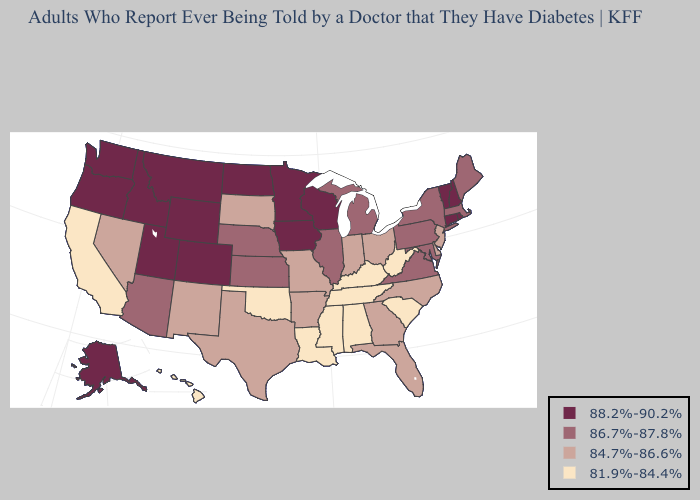How many symbols are there in the legend?
Be succinct. 4. Name the states that have a value in the range 88.2%-90.2%?
Answer briefly. Alaska, Colorado, Connecticut, Idaho, Iowa, Minnesota, Montana, New Hampshire, North Dakota, Oregon, Rhode Island, Utah, Vermont, Washington, Wisconsin, Wyoming. Which states have the highest value in the USA?
Concise answer only. Alaska, Colorado, Connecticut, Idaho, Iowa, Minnesota, Montana, New Hampshire, North Dakota, Oregon, Rhode Island, Utah, Vermont, Washington, Wisconsin, Wyoming. Does the first symbol in the legend represent the smallest category?
Keep it brief. No. What is the highest value in states that border California?
Short answer required. 88.2%-90.2%. Among the states that border Missouri , which have the highest value?
Be succinct. Iowa. Name the states that have a value in the range 81.9%-84.4%?
Concise answer only. Alabama, California, Hawaii, Kentucky, Louisiana, Mississippi, Oklahoma, South Carolina, Tennessee, West Virginia. Does Hawaii have the highest value in the West?
Be succinct. No. What is the lowest value in the Northeast?
Be succinct. 84.7%-86.6%. What is the value of Alabama?
Short answer required. 81.9%-84.4%. Does Tennessee have a lower value than Ohio?
Answer briefly. Yes. What is the value of Rhode Island?
Concise answer only. 88.2%-90.2%. What is the lowest value in the South?
Keep it brief. 81.9%-84.4%. Name the states that have a value in the range 84.7%-86.6%?
Be succinct. Arkansas, Delaware, Florida, Georgia, Indiana, Missouri, Nevada, New Jersey, New Mexico, North Carolina, Ohio, South Dakota, Texas. Which states have the lowest value in the USA?
Keep it brief. Alabama, California, Hawaii, Kentucky, Louisiana, Mississippi, Oklahoma, South Carolina, Tennessee, West Virginia. 